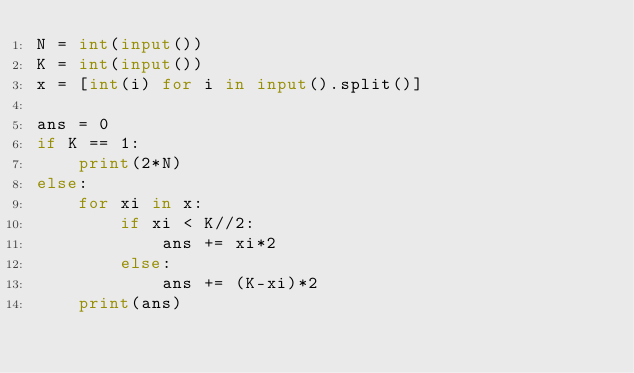Convert code to text. <code><loc_0><loc_0><loc_500><loc_500><_Python_>N = int(input())
K = int(input())
x = [int(i) for i in input().split()]

ans = 0
if K == 1:
    print(2*N)
else:
    for xi in x:
        if xi < K//2:
            ans += xi*2
        else:
            ans += (K-xi)*2
    print(ans)  </code> 